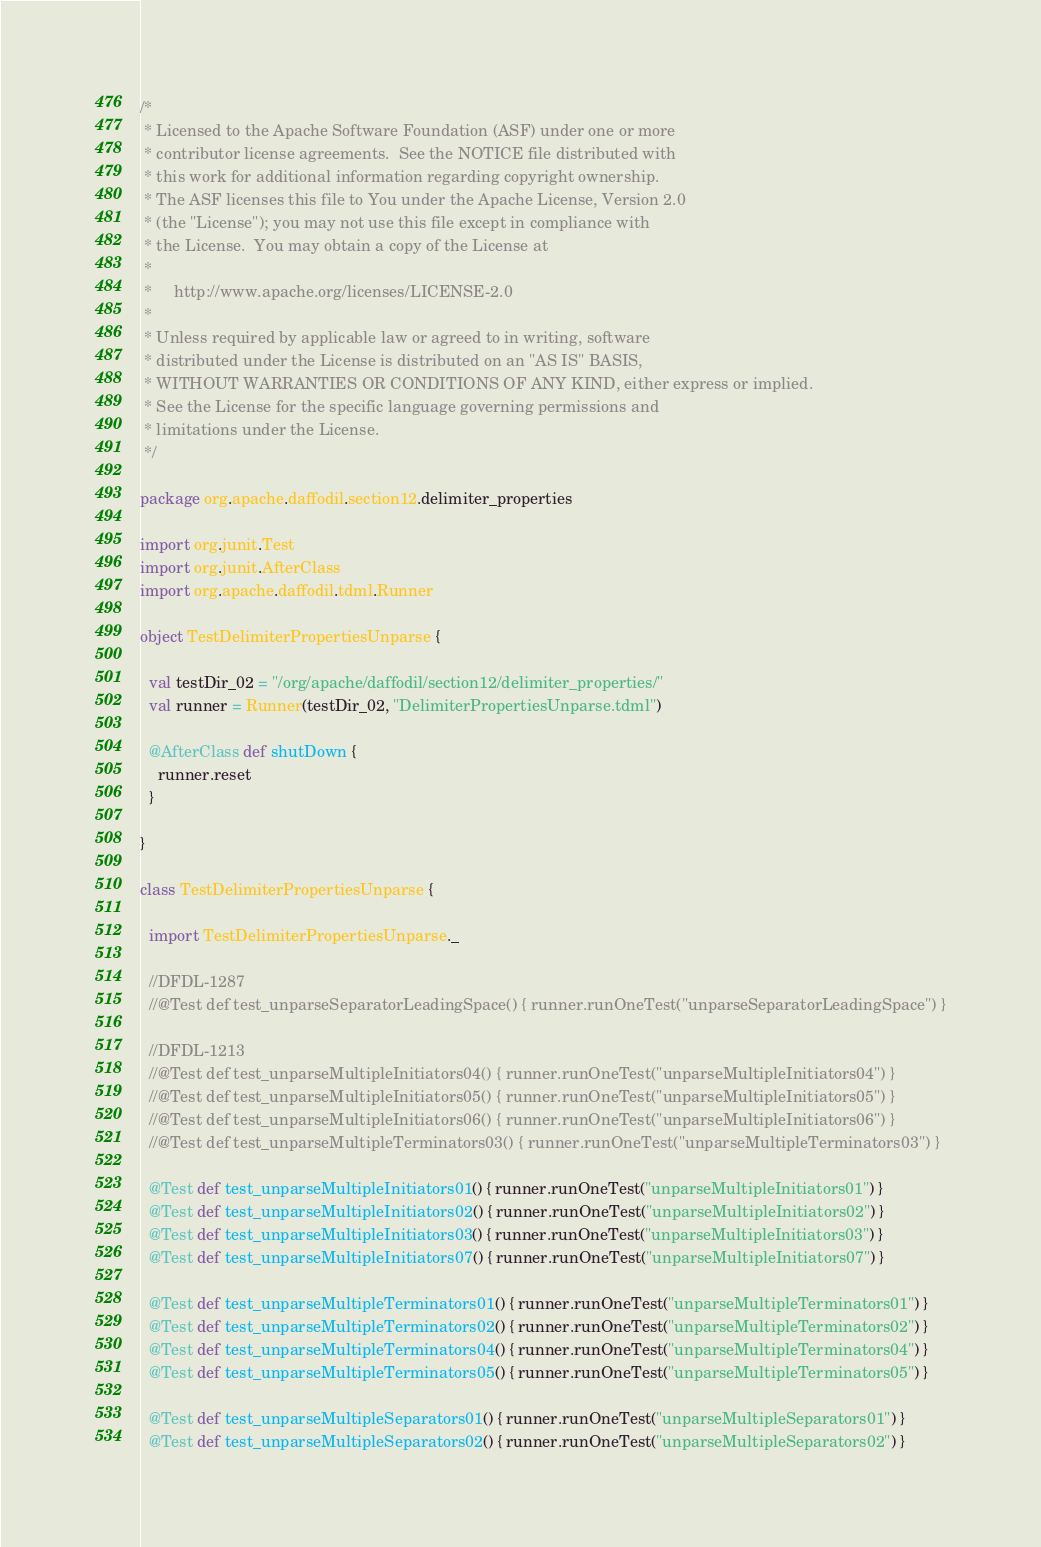<code> <loc_0><loc_0><loc_500><loc_500><_Scala_>/*
 * Licensed to the Apache Software Foundation (ASF) under one or more
 * contributor license agreements.  See the NOTICE file distributed with
 * this work for additional information regarding copyright ownership.
 * The ASF licenses this file to You under the Apache License, Version 2.0
 * (the "License"); you may not use this file except in compliance with
 * the License.  You may obtain a copy of the License at
 *
 *     http://www.apache.org/licenses/LICENSE-2.0
 *
 * Unless required by applicable law or agreed to in writing, software
 * distributed under the License is distributed on an "AS IS" BASIS,
 * WITHOUT WARRANTIES OR CONDITIONS OF ANY KIND, either express or implied.
 * See the License for the specific language governing permissions and
 * limitations under the License.
 */

package org.apache.daffodil.section12.delimiter_properties

import org.junit.Test
import org.junit.AfterClass
import org.apache.daffodil.tdml.Runner

object TestDelimiterPropertiesUnparse {

  val testDir_02 = "/org/apache/daffodil/section12/delimiter_properties/"
  val runner = Runner(testDir_02, "DelimiterPropertiesUnparse.tdml")

  @AfterClass def shutDown {
    runner.reset
  }

}

class TestDelimiterPropertiesUnparse {

  import TestDelimiterPropertiesUnparse._

  //DFDL-1287
  //@Test def test_unparseSeparatorLeadingSpace() { runner.runOneTest("unparseSeparatorLeadingSpace") }

  //DFDL-1213
  //@Test def test_unparseMultipleInitiators04() { runner.runOneTest("unparseMultipleInitiators04") }
  //@Test def test_unparseMultipleInitiators05() { runner.runOneTest("unparseMultipleInitiators05") }
  //@Test def test_unparseMultipleInitiators06() { runner.runOneTest("unparseMultipleInitiators06") }
  //@Test def test_unparseMultipleTerminators03() { runner.runOneTest("unparseMultipleTerminators03") }

  @Test def test_unparseMultipleInitiators01() { runner.runOneTest("unparseMultipleInitiators01") }
  @Test def test_unparseMultipleInitiators02() { runner.runOneTest("unparseMultipleInitiators02") }
  @Test def test_unparseMultipleInitiators03() { runner.runOneTest("unparseMultipleInitiators03") }
  @Test def test_unparseMultipleInitiators07() { runner.runOneTest("unparseMultipleInitiators07") }

  @Test def test_unparseMultipleTerminators01() { runner.runOneTest("unparseMultipleTerminators01") }
  @Test def test_unparseMultipleTerminators02() { runner.runOneTest("unparseMultipleTerminators02") }
  @Test def test_unparseMultipleTerminators04() { runner.runOneTest("unparseMultipleTerminators04") }
  @Test def test_unparseMultipleTerminators05() { runner.runOneTest("unparseMultipleTerminators05") }

  @Test def test_unparseMultipleSeparators01() { runner.runOneTest("unparseMultipleSeparators01") }
  @Test def test_unparseMultipleSeparators02() { runner.runOneTest("unparseMultipleSeparators02") }</code> 